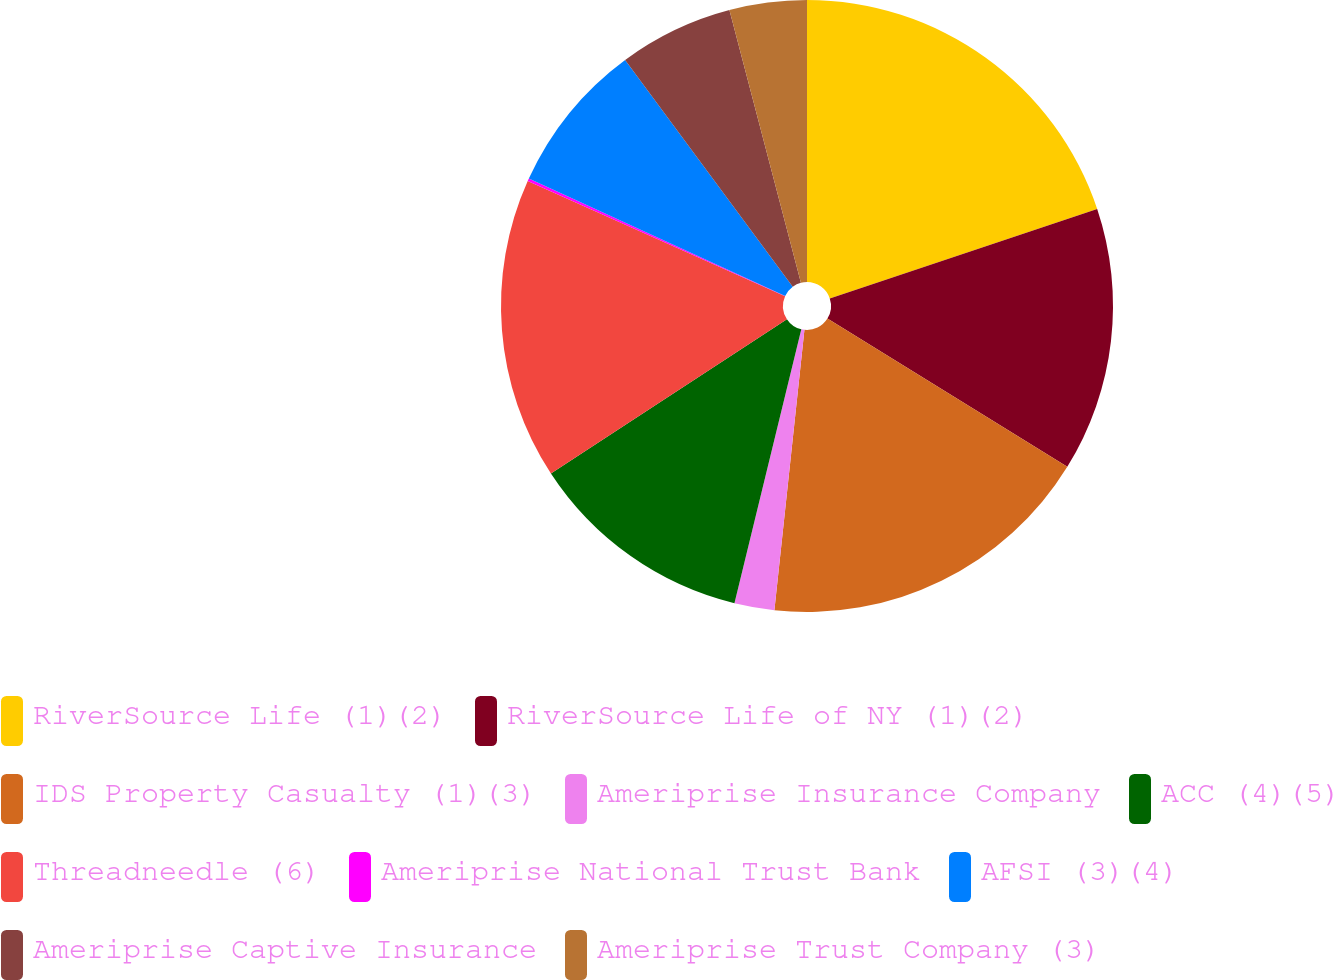Convert chart. <chart><loc_0><loc_0><loc_500><loc_500><pie_chart><fcel>RiverSource Life (1)(2)<fcel>RiverSource Life of NY (1)(2)<fcel>IDS Property Casualty (1)(3)<fcel>Ameriprise Insurance Company<fcel>ACC (4)(5)<fcel>Threadneedle (6)<fcel>Ameriprise National Trust Bank<fcel>AFSI (3)(4)<fcel>Ameriprise Captive Insurance<fcel>Ameriprise Trust Company (3)<nl><fcel>19.86%<fcel>13.95%<fcel>17.89%<fcel>2.11%<fcel>11.97%<fcel>15.92%<fcel>0.14%<fcel>8.03%<fcel>6.05%<fcel>4.08%<nl></chart> 